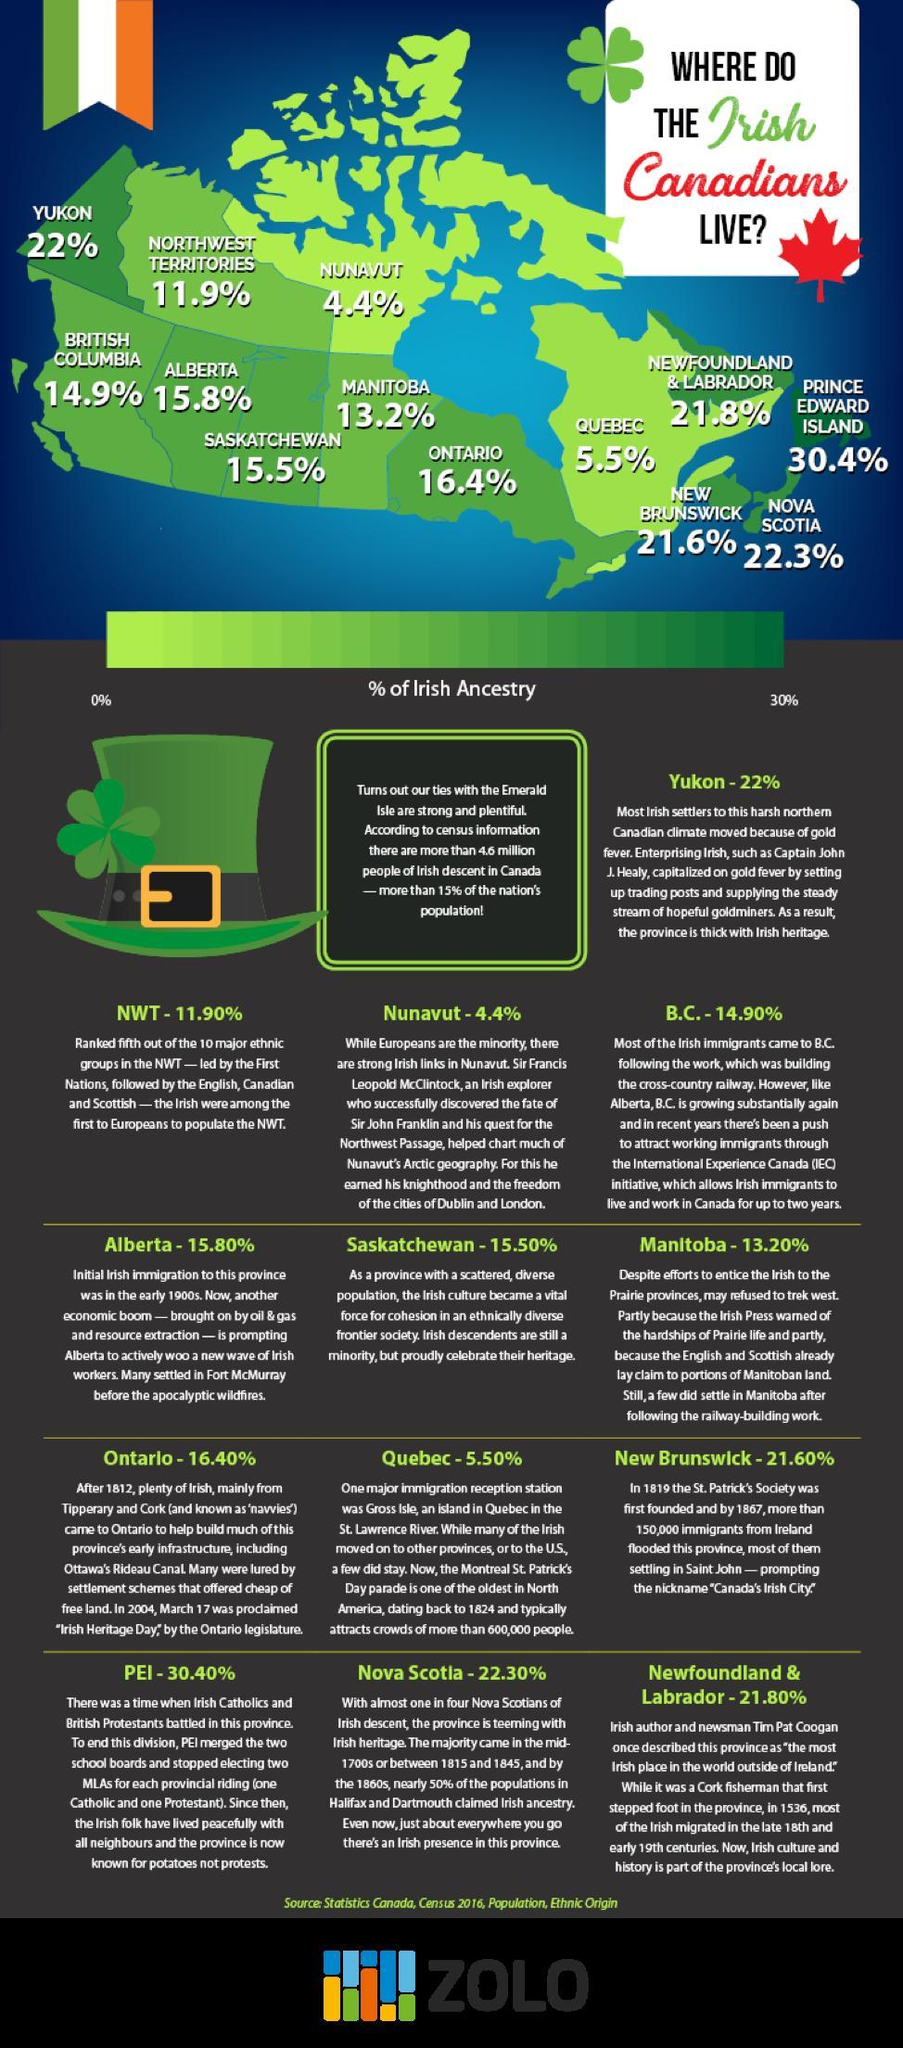Which place has the highest population of Irish people in Canada?
Answer the question with a short phrase. PRINCE EDWARD ISLAND 